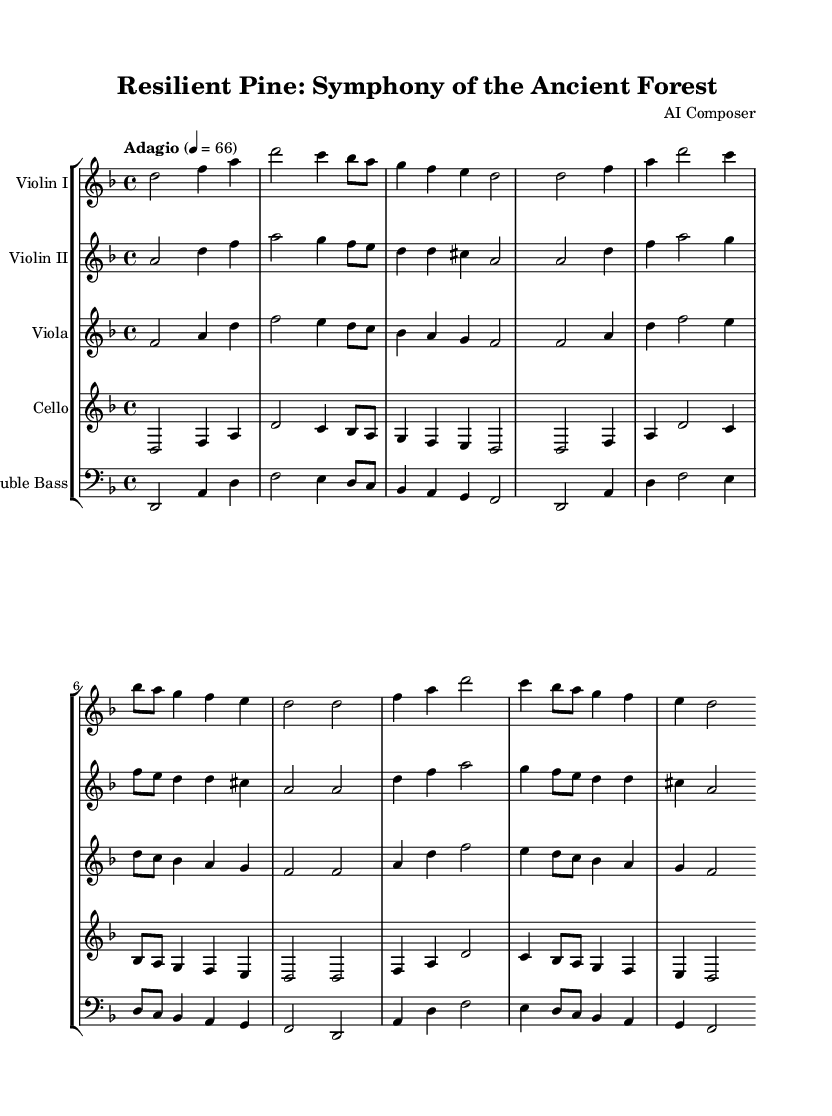What is the title of this composition? The title is indicated at the beginning of the sheet music and reads "Resilient Pine: Symphony of the Ancient Forest."
Answer: Resilient Pine: Symphony of the Ancient Forest What is the key signature of this music? The key is marked as D minor; it has one flat (B flat) that indicates this key signature.
Answer: D minor What is the time signature of this piece? The time signature is present in the top left corner of the sheet music, which displays 4/4.
Answer: 4/4 What is the tempo marking of this composition? The tempo is given with "Adagio" and a metronome marking of 66 beats per minute, indicating a slow pace.
Answer: Adagio, 4 = 66 How many times is the violin I part repeated? The violin I part includes a repeat sign which indicates that the section is played twice.
Answer: 2 Which instruments are featured in the orchestration? The orchestration includes Violin I, Violin II, Viola, Cello, and Double Bass, as listed in the score.
Answer: Violin I, Violin II, Viola, Cello, Double Bass What is the rhythmic complexity of this piece? The piece mainly comprises half notes, quarter notes, and eighth notes, with emphasis on maintaining a steady and lyrical rhythm throughout.
Answer: Lyrical rhythm 